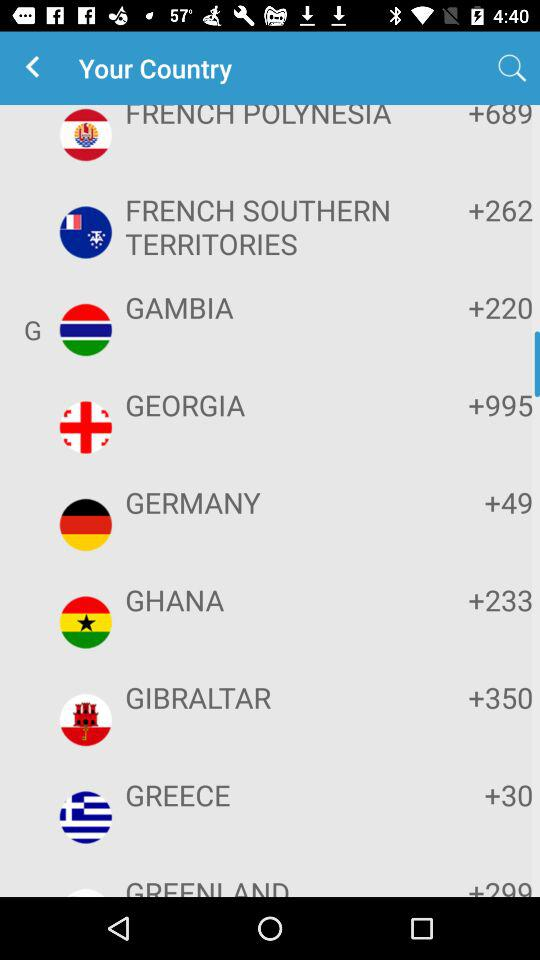Which country code is +233? The country code of Ghana is +233. 